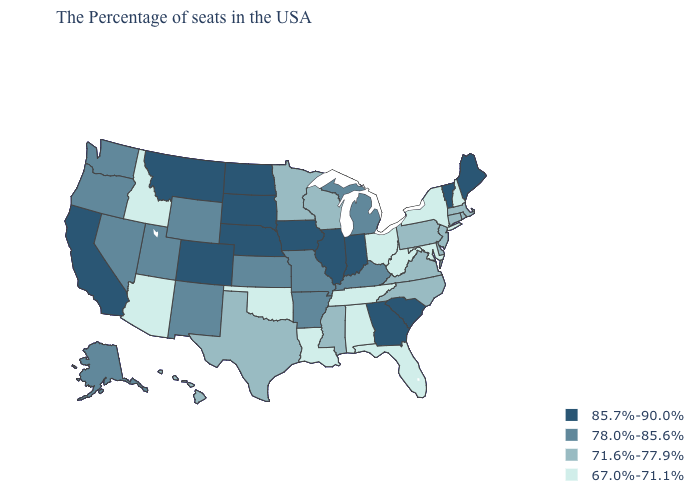Does Ohio have the highest value in the MidWest?
Be succinct. No. How many symbols are there in the legend?
Write a very short answer. 4. What is the highest value in states that border Colorado?
Concise answer only. 85.7%-90.0%. How many symbols are there in the legend?
Give a very brief answer. 4. Name the states that have a value in the range 71.6%-77.9%?
Write a very short answer. Massachusetts, Rhode Island, Connecticut, New Jersey, Delaware, Pennsylvania, Virginia, North Carolina, Wisconsin, Mississippi, Minnesota, Texas, Hawaii. Which states hav the highest value in the South?
Be succinct. South Carolina, Georgia. Which states have the highest value in the USA?
Quick response, please. Maine, Vermont, South Carolina, Georgia, Indiana, Illinois, Iowa, Nebraska, South Dakota, North Dakota, Colorado, Montana, California. What is the value of Michigan?
Be succinct. 78.0%-85.6%. What is the lowest value in the South?
Concise answer only. 67.0%-71.1%. Does Indiana have the same value as California?
Give a very brief answer. Yes. What is the value of Wisconsin?
Quick response, please. 71.6%-77.9%. Name the states that have a value in the range 71.6%-77.9%?
Short answer required. Massachusetts, Rhode Island, Connecticut, New Jersey, Delaware, Pennsylvania, Virginia, North Carolina, Wisconsin, Mississippi, Minnesota, Texas, Hawaii. Name the states that have a value in the range 78.0%-85.6%?
Keep it brief. Michigan, Kentucky, Missouri, Arkansas, Kansas, Wyoming, New Mexico, Utah, Nevada, Washington, Oregon, Alaska. Which states hav the highest value in the West?
Short answer required. Colorado, Montana, California. 